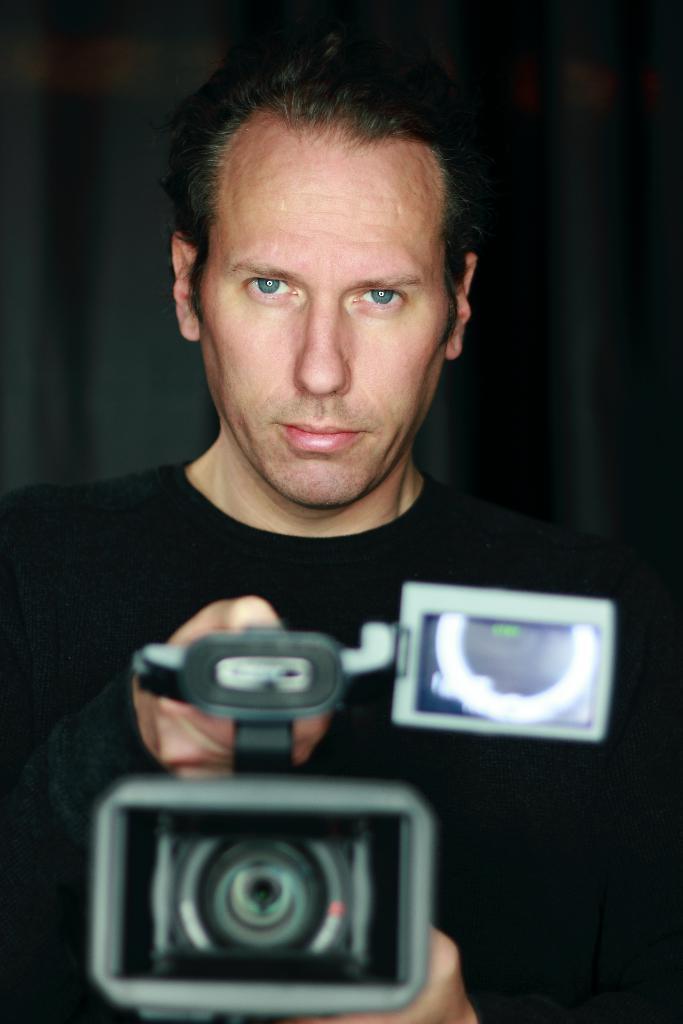How would you summarize this image in a sentence or two? In the image we can see there is a person who is standing and he is wearing a black colour shirt and holding a video camera in his hand. 